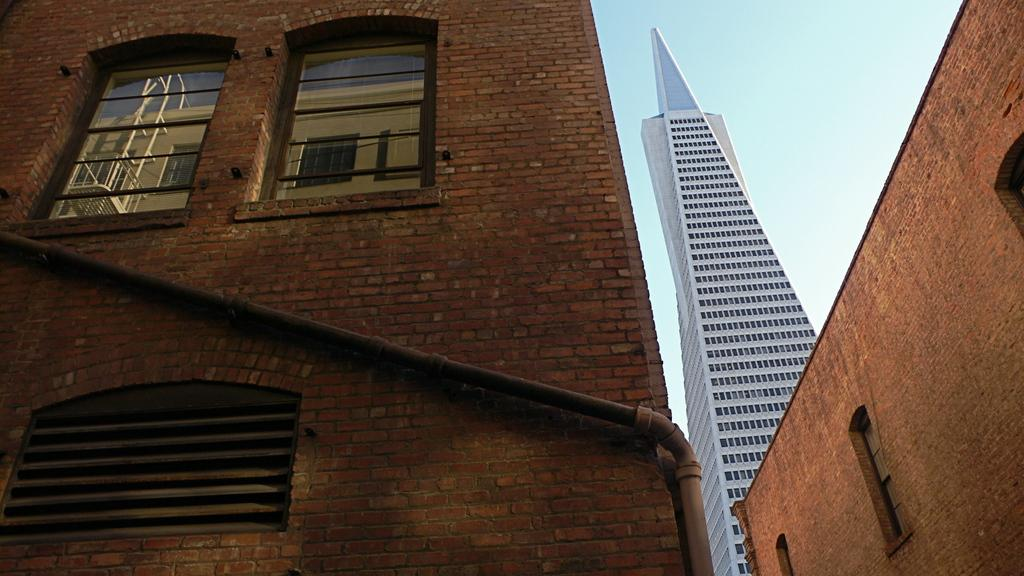What type of structures can be seen in the image? There are buildings in the image. Can you describe any specific features of the buildings? There are windows visible in the image. What else is present in the image besides the buildings? There is a pipe in the image. What can be seen in the background of the image? The sky is visible in the background of the image. What type of harmony can be heard in the image? There is no audible sound or music present in the image, so it is not possible to determine if any harmony can be heard. 